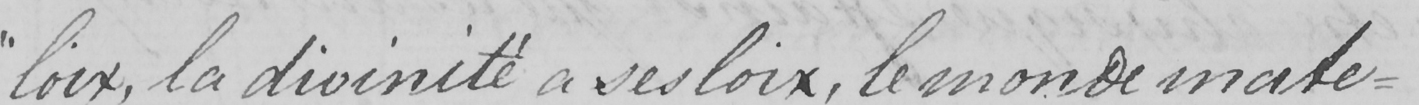What does this handwritten line say? " loix , la divinitè a ses loix , le monde mate= 